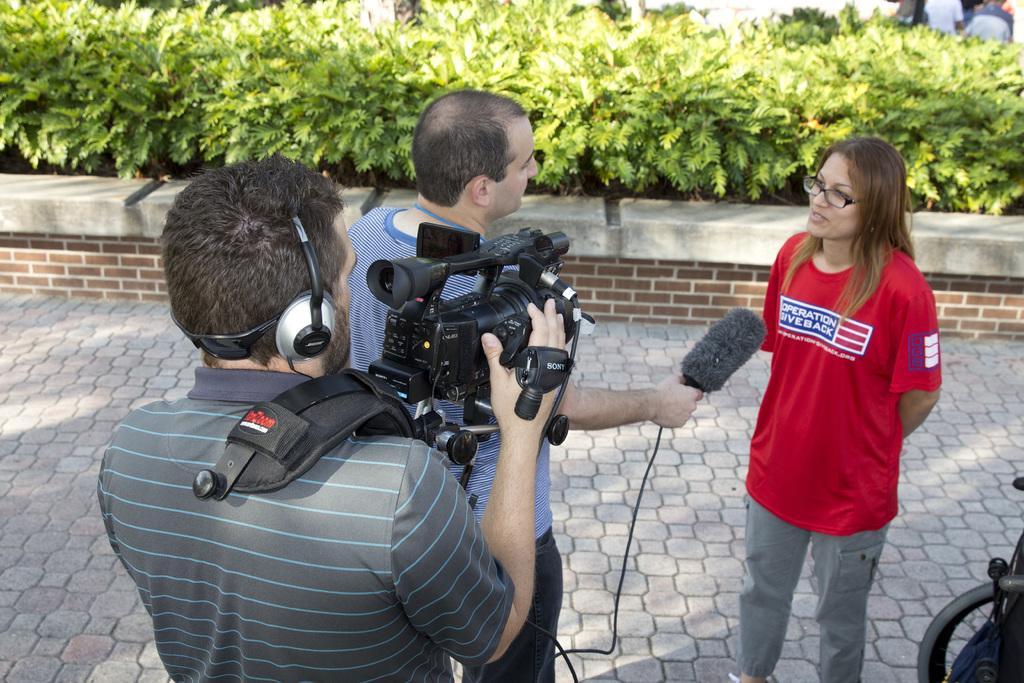Please provide a concise description of this image. In this image in the front there are group of persons. In the background there are plants and there is a wall. In the front there is a man standing and holding a camera. In the center there is a person holding a mic and on the right side there is a woman speaking in front of the mic and smiling. On the right side there is an object which is black in colour. In the background there are persons visible. 